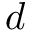Convert formula to latex. <formula><loc_0><loc_0><loc_500><loc_500>d</formula> 